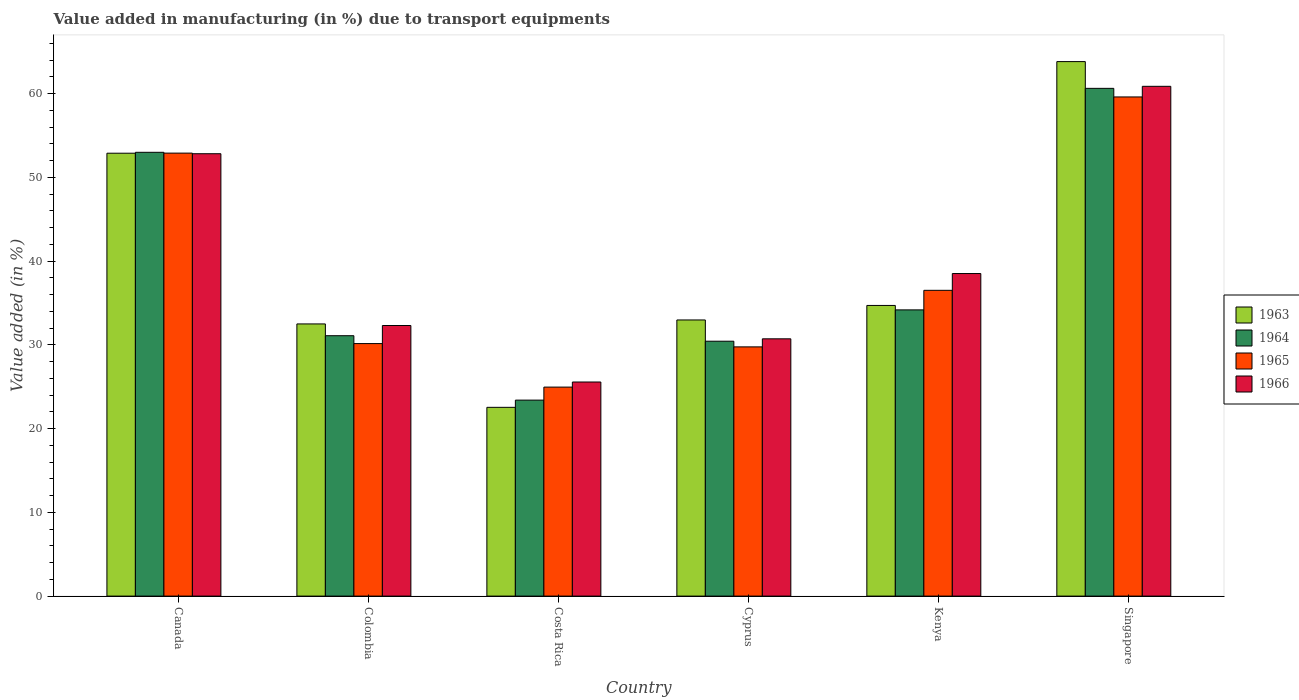How many different coloured bars are there?
Your answer should be compact. 4. How many groups of bars are there?
Keep it short and to the point. 6. How many bars are there on the 1st tick from the left?
Offer a very short reply. 4. What is the label of the 6th group of bars from the left?
Provide a short and direct response. Singapore. In how many cases, is the number of bars for a given country not equal to the number of legend labels?
Keep it short and to the point. 0. What is the percentage of value added in manufacturing due to transport equipments in 1965 in Cyprus?
Your answer should be compact. 29.75. Across all countries, what is the maximum percentage of value added in manufacturing due to transport equipments in 1964?
Provide a short and direct response. 60.62. Across all countries, what is the minimum percentage of value added in manufacturing due to transport equipments in 1964?
Your answer should be very brief. 23.4. In which country was the percentage of value added in manufacturing due to transport equipments in 1965 maximum?
Your response must be concise. Singapore. What is the total percentage of value added in manufacturing due to transport equipments in 1964 in the graph?
Offer a very short reply. 232.68. What is the difference between the percentage of value added in manufacturing due to transport equipments in 1963 in Costa Rica and that in Singapore?
Ensure brevity in your answer.  -41.28. What is the difference between the percentage of value added in manufacturing due to transport equipments in 1966 in Singapore and the percentage of value added in manufacturing due to transport equipments in 1963 in Costa Rica?
Give a very brief answer. 38.33. What is the average percentage of value added in manufacturing due to transport equipments in 1965 per country?
Provide a short and direct response. 38.97. What is the difference between the percentage of value added in manufacturing due to transport equipments of/in 1963 and percentage of value added in manufacturing due to transport equipments of/in 1964 in Colombia?
Give a very brief answer. 1.41. In how many countries, is the percentage of value added in manufacturing due to transport equipments in 1964 greater than 6 %?
Offer a terse response. 6. What is the ratio of the percentage of value added in manufacturing due to transport equipments in 1964 in Costa Rica to that in Kenya?
Give a very brief answer. 0.68. Is the percentage of value added in manufacturing due to transport equipments in 1963 in Colombia less than that in Costa Rica?
Make the answer very short. No. Is the difference between the percentage of value added in manufacturing due to transport equipments in 1963 in Colombia and Kenya greater than the difference between the percentage of value added in manufacturing due to transport equipments in 1964 in Colombia and Kenya?
Provide a succinct answer. Yes. What is the difference between the highest and the second highest percentage of value added in manufacturing due to transport equipments in 1964?
Provide a short and direct response. -26.45. What is the difference between the highest and the lowest percentage of value added in manufacturing due to transport equipments in 1964?
Give a very brief answer. 37.22. In how many countries, is the percentage of value added in manufacturing due to transport equipments in 1963 greater than the average percentage of value added in manufacturing due to transport equipments in 1963 taken over all countries?
Ensure brevity in your answer.  2. Is the sum of the percentage of value added in manufacturing due to transport equipments in 1966 in Cyprus and Singapore greater than the maximum percentage of value added in manufacturing due to transport equipments in 1964 across all countries?
Provide a short and direct response. Yes. What does the 2nd bar from the left in Canada represents?
Keep it short and to the point. 1964. How many bars are there?
Your answer should be very brief. 24. Are all the bars in the graph horizontal?
Offer a very short reply. No. How many countries are there in the graph?
Your response must be concise. 6. Does the graph contain any zero values?
Keep it short and to the point. No. Does the graph contain grids?
Make the answer very short. No. Where does the legend appear in the graph?
Provide a short and direct response. Center right. How many legend labels are there?
Keep it short and to the point. 4. What is the title of the graph?
Make the answer very short. Value added in manufacturing (in %) due to transport equipments. Does "2003" appear as one of the legend labels in the graph?
Keep it short and to the point. No. What is the label or title of the Y-axis?
Give a very brief answer. Value added (in %). What is the Value added (in %) of 1963 in Canada?
Your response must be concise. 52.87. What is the Value added (in %) of 1964 in Canada?
Provide a succinct answer. 52.98. What is the Value added (in %) of 1965 in Canada?
Provide a short and direct response. 52.89. What is the Value added (in %) of 1966 in Canada?
Keep it short and to the point. 52.81. What is the Value added (in %) in 1963 in Colombia?
Give a very brief answer. 32.49. What is the Value added (in %) in 1964 in Colombia?
Provide a short and direct response. 31.09. What is the Value added (in %) in 1965 in Colombia?
Ensure brevity in your answer.  30.15. What is the Value added (in %) of 1966 in Colombia?
Make the answer very short. 32.3. What is the Value added (in %) in 1963 in Costa Rica?
Offer a terse response. 22.53. What is the Value added (in %) in 1964 in Costa Rica?
Offer a terse response. 23.4. What is the Value added (in %) in 1965 in Costa Rica?
Make the answer very short. 24.95. What is the Value added (in %) of 1966 in Costa Rica?
Your response must be concise. 25.56. What is the Value added (in %) of 1963 in Cyprus?
Give a very brief answer. 32.97. What is the Value added (in %) in 1964 in Cyprus?
Ensure brevity in your answer.  30.43. What is the Value added (in %) in 1965 in Cyprus?
Offer a very short reply. 29.75. What is the Value added (in %) in 1966 in Cyprus?
Keep it short and to the point. 30.72. What is the Value added (in %) in 1963 in Kenya?
Provide a succinct answer. 34.7. What is the Value added (in %) in 1964 in Kenya?
Give a very brief answer. 34.17. What is the Value added (in %) of 1965 in Kenya?
Provide a short and direct response. 36.5. What is the Value added (in %) of 1966 in Kenya?
Give a very brief answer. 38.51. What is the Value added (in %) of 1963 in Singapore?
Keep it short and to the point. 63.81. What is the Value added (in %) of 1964 in Singapore?
Your response must be concise. 60.62. What is the Value added (in %) in 1965 in Singapore?
Your response must be concise. 59.59. What is the Value added (in %) of 1966 in Singapore?
Keep it short and to the point. 60.86. Across all countries, what is the maximum Value added (in %) in 1963?
Your answer should be compact. 63.81. Across all countries, what is the maximum Value added (in %) of 1964?
Ensure brevity in your answer.  60.62. Across all countries, what is the maximum Value added (in %) of 1965?
Your response must be concise. 59.59. Across all countries, what is the maximum Value added (in %) of 1966?
Provide a succinct answer. 60.86. Across all countries, what is the minimum Value added (in %) of 1963?
Provide a succinct answer. 22.53. Across all countries, what is the minimum Value added (in %) of 1964?
Make the answer very short. 23.4. Across all countries, what is the minimum Value added (in %) of 1965?
Your response must be concise. 24.95. Across all countries, what is the minimum Value added (in %) of 1966?
Provide a short and direct response. 25.56. What is the total Value added (in %) in 1963 in the graph?
Your response must be concise. 239.38. What is the total Value added (in %) in 1964 in the graph?
Make the answer very short. 232.68. What is the total Value added (in %) in 1965 in the graph?
Your answer should be very brief. 233.83. What is the total Value added (in %) of 1966 in the graph?
Keep it short and to the point. 240.76. What is the difference between the Value added (in %) of 1963 in Canada and that in Colombia?
Give a very brief answer. 20.38. What is the difference between the Value added (in %) in 1964 in Canada and that in Colombia?
Make the answer very short. 21.9. What is the difference between the Value added (in %) of 1965 in Canada and that in Colombia?
Make the answer very short. 22.74. What is the difference between the Value added (in %) of 1966 in Canada and that in Colombia?
Offer a terse response. 20.51. What is the difference between the Value added (in %) in 1963 in Canada and that in Costa Rica?
Offer a terse response. 30.34. What is the difference between the Value added (in %) of 1964 in Canada and that in Costa Rica?
Your answer should be very brief. 29.59. What is the difference between the Value added (in %) in 1965 in Canada and that in Costa Rica?
Your answer should be very brief. 27.93. What is the difference between the Value added (in %) of 1966 in Canada and that in Costa Rica?
Provide a succinct answer. 27.25. What is the difference between the Value added (in %) in 1963 in Canada and that in Cyprus?
Your answer should be very brief. 19.91. What is the difference between the Value added (in %) of 1964 in Canada and that in Cyprus?
Offer a terse response. 22.55. What is the difference between the Value added (in %) in 1965 in Canada and that in Cyprus?
Offer a terse response. 23.13. What is the difference between the Value added (in %) in 1966 in Canada and that in Cyprus?
Offer a terse response. 22.1. What is the difference between the Value added (in %) in 1963 in Canada and that in Kenya?
Your answer should be compact. 18.17. What is the difference between the Value added (in %) of 1964 in Canada and that in Kenya?
Keep it short and to the point. 18.81. What is the difference between the Value added (in %) in 1965 in Canada and that in Kenya?
Make the answer very short. 16.38. What is the difference between the Value added (in %) in 1966 in Canada and that in Kenya?
Give a very brief answer. 14.3. What is the difference between the Value added (in %) in 1963 in Canada and that in Singapore?
Your answer should be compact. -10.94. What is the difference between the Value added (in %) in 1964 in Canada and that in Singapore?
Offer a terse response. -7.63. What is the difference between the Value added (in %) of 1965 in Canada and that in Singapore?
Provide a short and direct response. -6.71. What is the difference between the Value added (in %) of 1966 in Canada and that in Singapore?
Offer a terse response. -8.05. What is the difference between the Value added (in %) in 1963 in Colombia and that in Costa Rica?
Ensure brevity in your answer.  9.96. What is the difference between the Value added (in %) of 1964 in Colombia and that in Costa Rica?
Keep it short and to the point. 7.69. What is the difference between the Value added (in %) of 1965 in Colombia and that in Costa Rica?
Your answer should be compact. 5.2. What is the difference between the Value added (in %) of 1966 in Colombia and that in Costa Rica?
Offer a terse response. 6.74. What is the difference between the Value added (in %) in 1963 in Colombia and that in Cyprus?
Provide a succinct answer. -0.47. What is the difference between the Value added (in %) of 1964 in Colombia and that in Cyprus?
Provide a succinct answer. 0.66. What is the difference between the Value added (in %) of 1965 in Colombia and that in Cyprus?
Provide a short and direct response. 0.39. What is the difference between the Value added (in %) in 1966 in Colombia and that in Cyprus?
Provide a short and direct response. 1.59. What is the difference between the Value added (in %) of 1963 in Colombia and that in Kenya?
Offer a very short reply. -2.21. What is the difference between the Value added (in %) of 1964 in Colombia and that in Kenya?
Your response must be concise. -3.08. What is the difference between the Value added (in %) in 1965 in Colombia and that in Kenya?
Keep it short and to the point. -6.36. What is the difference between the Value added (in %) in 1966 in Colombia and that in Kenya?
Keep it short and to the point. -6.2. What is the difference between the Value added (in %) of 1963 in Colombia and that in Singapore?
Give a very brief answer. -31.32. What is the difference between the Value added (in %) in 1964 in Colombia and that in Singapore?
Provide a succinct answer. -29.53. What is the difference between the Value added (in %) of 1965 in Colombia and that in Singapore?
Make the answer very short. -29.45. What is the difference between the Value added (in %) in 1966 in Colombia and that in Singapore?
Your response must be concise. -28.56. What is the difference between the Value added (in %) of 1963 in Costa Rica and that in Cyprus?
Your answer should be compact. -10.43. What is the difference between the Value added (in %) of 1964 in Costa Rica and that in Cyprus?
Offer a very short reply. -7.03. What is the difference between the Value added (in %) of 1965 in Costa Rica and that in Cyprus?
Offer a very short reply. -4.8. What is the difference between the Value added (in %) in 1966 in Costa Rica and that in Cyprus?
Provide a succinct answer. -5.16. What is the difference between the Value added (in %) in 1963 in Costa Rica and that in Kenya?
Give a very brief answer. -12.17. What is the difference between the Value added (in %) of 1964 in Costa Rica and that in Kenya?
Make the answer very short. -10.77. What is the difference between the Value added (in %) in 1965 in Costa Rica and that in Kenya?
Your answer should be compact. -11.55. What is the difference between the Value added (in %) of 1966 in Costa Rica and that in Kenya?
Your answer should be compact. -12.95. What is the difference between the Value added (in %) in 1963 in Costa Rica and that in Singapore?
Offer a very short reply. -41.28. What is the difference between the Value added (in %) in 1964 in Costa Rica and that in Singapore?
Keep it short and to the point. -37.22. What is the difference between the Value added (in %) of 1965 in Costa Rica and that in Singapore?
Your answer should be very brief. -34.64. What is the difference between the Value added (in %) in 1966 in Costa Rica and that in Singapore?
Offer a terse response. -35.3. What is the difference between the Value added (in %) of 1963 in Cyprus and that in Kenya?
Provide a short and direct response. -1.73. What is the difference between the Value added (in %) of 1964 in Cyprus and that in Kenya?
Give a very brief answer. -3.74. What is the difference between the Value added (in %) in 1965 in Cyprus and that in Kenya?
Your answer should be very brief. -6.75. What is the difference between the Value added (in %) of 1966 in Cyprus and that in Kenya?
Offer a very short reply. -7.79. What is the difference between the Value added (in %) in 1963 in Cyprus and that in Singapore?
Ensure brevity in your answer.  -30.84. What is the difference between the Value added (in %) of 1964 in Cyprus and that in Singapore?
Make the answer very short. -30.19. What is the difference between the Value added (in %) of 1965 in Cyprus and that in Singapore?
Provide a short and direct response. -29.84. What is the difference between the Value added (in %) of 1966 in Cyprus and that in Singapore?
Provide a succinct answer. -30.14. What is the difference between the Value added (in %) of 1963 in Kenya and that in Singapore?
Offer a terse response. -29.11. What is the difference between the Value added (in %) of 1964 in Kenya and that in Singapore?
Make the answer very short. -26.45. What is the difference between the Value added (in %) in 1965 in Kenya and that in Singapore?
Make the answer very short. -23.09. What is the difference between the Value added (in %) of 1966 in Kenya and that in Singapore?
Offer a very short reply. -22.35. What is the difference between the Value added (in %) of 1963 in Canada and the Value added (in %) of 1964 in Colombia?
Ensure brevity in your answer.  21.79. What is the difference between the Value added (in %) in 1963 in Canada and the Value added (in %) in 1965 in Colombia?
Provide a short and direct response. 22.73. What is the difference between the Value added (in %) in 1963 in Canada and the Value added (in %) in 1966 in Colombia?
Make the answer very short. 20.57. What is the difference between the Value added (in %) in 1964 in Canada and the Value added (in %) in 1965 in Colombia?
Keep it short and to the point. 22.84. What is the difference between the Value added (in %) in 1964 in Canada and the Value added (in %) in 1966 in Colombia?
Ensure brevity in your answer.  20.68. What is the difference between the Value added (in %) in 1965 in Canada and the Value added (in %) in 1966 in Colombia?
Keep it short and to the point. 20.58. What is the difference between the Value added (in %) in 1963 in Canada and the Value added (in %) in 1964 in Costa Rica?
Keep it short and to the point. 29.48. What is the difference between the Value added (in %) of 1963 in Canada and the Value added (in %) of 1965 in Costa Rica?
Ensure brevity in your answer.  27.92. What is the difference between the Value added (in %) of 1963 in Canada and the Value added (in %) of 1966 in Costa Rica?
Keep it short and to the point. 27.31. What is the difference between the Value added (in %) in 1964 in Canada and the Value added (in %) in 1965 in Costa Rica?
Offer a very short reply. 28.03. What is the difference between the Value added (in %) of 1964 in Canada and the Value added (in %) of 1966 in Costa Rica?
Your response must be concise. 27.42. What is the difference between the Value added (in %) of 1965 in Canada and the Value added (in %) of 1966 in Costa Rica?
Give a very brief answer. 27.33. What is the difference between the Value added (in %) of 1963 in Canada and the Value added (in %) of 1964 in Cyprus?
Ensure brevity in your answer.  22.44. What is the difference between the Value added (in %) in 1963 in Canada and the Value added (in %) in 1965 in Cyprus?
Keep it short and to the point. 23.12. What is the difference between the Value added (in %) in 1963 in Canada and the Value added (in %) in 1966 in Cyprus?
Keep it short and to the point. 22.16. What is the difference between the Value added (in %) in 1964 in Canada and the Value added (in %) in 1965 in Cyprus?
Your answer should be compact. 23.23. What is the difference between the Value added (in %) of 1964 in Canada and the Value added (in %) of 1966 in Cyprus?
Offer a very short reply. 22.27. What is the difference between the Value added (in %) of 1965 in Canada and the Value added (in %) of 1966 in Cyprus?
Offer a very short reply. 22.17. What is the difference between the Value added (in %) of 1963 in Canada and the Value added (in %) of 1964 in Kenya?
Your answer should be very brief. 18.7. What is the difference between the Value added (in %) in 1963 in Canada and the Value added (in %) in 1965 in Kenya?
Offer a very short reply. 16.37. What is the difference between the Value added (in %) in 1963 in Canada and the Value added (in %) in 1966 in Kenya?
Keep it short and to the point. 14.37. What is the difference between the Value added (in %) in 1964 in Canada and the Value added (in %) in 1965 in Kenya?
Make the answer very short. 16.48. What is the difference between the Value added (in %) in 1964 in Canada and the Value added (in %) in 1966 in Kenya?
Offer a very short reply. 14.47. What is the difference between the Value added (in %) in 1965 in Canada and the Value added (in %) in 1966 in Kenya?
Ensure brevity in your answer.  14.38. What is the difference between the Value added (in %) in 1963 in Canada and the Value added (in %) in 1964 in Singapore?
Your answer should be very brief. -7.74. What is the difference between the Value added (in %) in 1963 in Canada and the Value added (in %) in 1965 in Singapore?
Provide a short and direct response. -6.72. What is the difference between the Value added (in %) in 1963 in Canada and the Value added (in %) in 1966 in Singapore?
Offer a terse response. -7.99. What is the difference between the Value added (in %) in 1964 in Canada and the Value added (in %) in 1965 in Singapore?
Offer a terse response. -6.61. What is the difference between the Value added (in %) of 1964 in Canada and the Value added (in %) of 1966 in Singapore?
Give a very brief answer. -7.88. What is the difference between the Value added (in %) in 1965 in Canada and the Value added (in %) in 1966 in Singapore?
Ensure brevity in your answer.  -7.97. What is the difference between the Value added (in %) of 1963 in Colombia and the Value added (in %) of 1964 in Costa Rica?
Your response must be concise. 9.1. What is the difference between the Value added (in %) of 1963 in Colombia and the Value added (in %) of 1965 in Costa Rica?
Ensure brevity in your answer.  7.54. What is the difference between the Value added (in %) in 1963 in Colombia and the Value added (in %) in 1966 in Costa Rica?
Your answer should be compact. 6.93. What is the difference between the Value added (in %) of 1964 in Colombia and the Value added (in %) of 1965 in Costa Rica?
Offer a terse response. 6.14. What is the difference between the Value added (in %) of 1964 in Colombia and the Value added (in %) of 1966 in Costa Rica?
Offer a very short reply. 5.53. What is the difference between the Value added (in %) of 1965 in Colombia and the Value added (in %) of 1966 in Costa Rica?
Provide a short and direct response. 4.59. What is the difference between the Value added (in %) of 1963 in Colombia and the Value added (in %) of 1964 in Cyprus?
Ensure brevity in your answer.  2.06. What is the difference between the Value added (in %) in 1963 in Colombia and the Value added (in %) in 1965 in Cyprus?
Give a very brief answer. 2.74. What is the difference between the Value added (in %) in 1963 in Colombia and the Value added (in %) in 1966 in Cyprus?
Provide a short and direct response. 1.78. What is the difference between the Value added (in %) in 1964 in Colombia and the Value added (in %) in 1965 in Cyprus?
Provide a succinct answer. 1.33. What is the difference between the Value added (in %) in 1964 in Colombia and the Value added (in %) in 1966 in Cyprus?
Keep it short and to the point. 0.37. What is the difference between the Value added (in %) in 1965 in Colombia and the Value added (in %) in 1966 in Cyprus?
Provide a short and direct response. -0.57. What is the difference between the Value added (in %) of 1963 in Colombia and the Value added (in %) of 1964 in Kenya?
Make the answer very short. -1.68. What is the difference between the Value added (in %) of 1963 in Colombia and the Value added (in %) of 1965 in Kenya?
Offer a very short reply. -4.01. What is the difference between the Value added (in %) of 1963 in Colombia and the Value added (in %) of 1966 in Kenya?
Provide a short and direct response. -6.01. What is the difference between the Value added (in %) of 1964 in Colombia and the Value added (in %) of 1965 in Kenya?
Your answer should be very brief. -5.42. What is the difference between the Value added (in %) in 1964 in Colombia and the Value added (in %) in 1966 in Kenya?
Keep it short and to the point. -7.42. What is the difference between the Value added (in %) of 1965 in Colombia and the Value added (in %) of 1966 in Kenya?
Provide a short and direct response. -8.36. What is the difference between the Value added (in %) of 1963 in Colombia and the Value added (in %) of 1964 in Singapore?
Ensure brevity in your answer.  -28.12. What is the difference between the Value added (in %) of 1963 in Colombia and the Value added (in %) of 1965 in Singapore?
Provide a succinct answer. -27.1. What is the difference between the Value added (in %) in 1963 in Colombia and the Value added (in %) in 1966 in Singapore?
Make the answer very short. -28.37. What is the difference between the Value added (in %) of 1964 in Colombia and the Value added (in %) of 1965 in Singapore?
Ensure brevity in your answer.  -28.51. What is the difference between the Value added (in %) of 1964 in Colombia and the Value added (in %) of 1966 in Singapore?
Make the answer very short. -29.77. What is the difference between the Value added (in %) of 1965 in Colombia and the Value added (in %) of 1966 in Singapore?
Provide a succinct answer. -30.71. What is the difference between the Value added (in %) in 1963 in Costa Rica and the Value added (in %) in 1964 in Cyprus?
Keep it short and to the point. -7.9. What is the difference between the Value added (in %) in 1963 in Costa Rica and the Value added (in %) in 1965 in Cyprus?
Keep it short and to the point. -7.22. What is the difference between the Value added (in %) in 1963 in Costa Rica and the Value added (in %) in 1966 in Cyprus?
Make the answer very short. -8.18. What is the difference between the Value added (in %) in 1964 in Costa Rica and the Value added (in %) in 1965 in Cyprus?
Provide a succinct answer. -6.36. What is the difference between the Value added (in %) in 1964 in Costa Rica and the Value added (in %) in 1966 in Cyprus?
Offer a very short reply. -7.32. What is the difference between the Value added (in %) of 1965 in Costa Rica and the Value added (in %) of 1966 in Cyprus?
Your answer should be very brief. -5.77. What is the difference between the Value added (in %) in 1963 in Costa Rica and the Value added (in %) in 1964 in Kenya?
Provide a short and direct response. -11.64. What is the difference between the Value added (in %) in 1963 in Costa Rica and the Value added (in %) in 1965 in Kenya?
Give a very brief answer. -13.97. What is the difference between the Value added (in %) of 1963 in Costa Rica and the Value added (in %) of 1966 in Kenya?
Provide a short and direct response. -15.97. What is the difference between the Value added (in %) of 1964 in Costa Rica and the Value added (in %) of 1965 in Kenya?
Offer a terse response. -13.11. What is the difference between the Value added (in %) in 1964 in Costa Rica and the Value added (in %) in 1966 in Kenya?
Make the answer very short. -15.11. What is the difference between the Value added (in %) of 1965 in Costa Rica and the Value added (in %) of 1966 in Kenya?
Give a very brief answer. -13.56. What is the difference between the Value added (in %) of 1963 in Costa Rica and the Value added (in %) of 1964 in Singapore?
Provide a succinct answer. -38.08. What is the difference between the Value added (in %) of 1963 in Costa Rica and the Value added (in %) of 1965 in Singapore?
Offer a very short reply. -37.06. What is the difference between the Value added (in %) in 1963 in Costa Rica and the Value added (in %) in 1966 in Singapore?
Provide a short and direct response. -38.33. What is the difference between the Value added (in %) in 1964 in Costa Rica and the Value added (in %) in 1965 in Singapore?
Provide a succinct answer. -36.19. What is the difference between the Value added (in %) of 1964 in Costa Rica and the Value added (in %) of 1966 in Singapore?
Your answer should be very brief. -37.46. What is the difference between the Value added (in %) in 1965 in Costa Rica and the Value added (in %) in 1966 in Singapore?
Offer a very short reply. -35.91. What is the difference between the Value added (in %) of 1963 in Cyprus and the Value added (in %) of 1964 in Kenya?
Provide a short and direct response. -1.2. What is the difference between the Value added (in %) in 1963 in Cyprus and the Value added (in %) in 1965 in Kenya?
Your answer should be very brief. -3.54. What is the difference between the Value added (in %) of 1963 in Cyprus and the Value added (in %) of 1966 in Kenya?
Offer a terse response. -5.54. What is the difference between the Value added (in %) of 1964 in Cyprus and the Value added (in %) of 1965 in Kenya?
Offer a terse response. -6.07. What is the difference between the Value added (in %) of 1964 in Cyprus and the Value added (in %) of 1966 in Kenya?
Provide a short and direct response. -8.08. What is the difference between the Value added (in %) of 1965 in Cyprus and the Value added (in %) of 1966 in Kenya?
Provide a succinct answer. -8.75. What is the difference between the Value added (in %) of 1963 in Cyprus and the Value added (in %) of 1964 in Singapore?
Keep it short and to the point. -27.65. What is the difference between the Value added (in %) of 1963 in Cyprus and the Value added (in %) of 1965 in Singapore?
Provide a succinct answer. -26.62. What is the difference between the Value added (in %) of 1963 in Cyprus and the Value added (in %) of 1966 in Singapore?
Ensure brevity in your answer.  -27.89. What is the difference between the Value added (in %) of 1964 in Cyprus and the Value added (in %) of 1965 in Singapore?
Your response must be concise. -29.16. What is the difference between the Value added (in %) of 1964 in Cyprus and the Value added (in %) of 1966 in Singapore?
Ensure brevity in your answer.  -30.43. What is the difference between the Value added (in %) of 1965 in Cyprus and the Value added (in %) of 1966 in Singapore?
Offer a terse response. -31.11. What is the difference between the Value added (in %) in 1963 in Kenya and the Value added (in %) in 1964 in Singapore?
Your response must be concise. -25.92. What is the difference between the Value added (in %) of 1963 in Kenya and the Value added (in %) of 1965 in Singapore?
Make the answer very short. -24.89. What is the difference between the Value added (in %) of 1963 in Kenya and the Value added (in %) of 1966 in Singapore?
Your answer should be compact. -26.16. What is the difference between the Value added (in %) of 1964 in Kenya and the Value added (in %) of 1965 in Singapore?
Provide a short and direct response. -25.42. What is the difference between the Value added (in %) of 1964 in Kenya and the Value added (in %) of 1966 in Singapore?
Provide a short and direct response. -26.69. What is the difference between the Value added (in %) in 1965 in Kenya and the Value added (in %) in 1966 in Singapore?
Provide a short and direct response. -24.36. What is the average Value added (in %) of 1963 per country?
Your response must be concise. 39.9. What is the average Value added (in %) in 1964 per country?
Your answer should be compact. 38.78. What is the average Value added (in %) of 1965 per country?
Your answer should be compact. 38.97. What is the average Value added (in %) of 1966 per country?
Offer a terse response. 40.13. What is the difference between the Value added (in %) of 1963 and Value added (in %) of 1964 in Canada?
Offer a terse response. -0.11. What is the difference between the Value added (in %) in 1963 and Value added (in %) in 1965 in Canada?
Keep it short and to the point. -0.01. What is the difference between the Value added (in %) in 1963 and Value added (in %) in 1966 in Canada?
Your answer should be very brief. 0.06. What is the difference between the Value added (in %) in 1964 and Value added (in %) in 1965 in Canada?
Your response must be concise. 0.1. What is the difference between the Value added (in %) in 1964 and Value added (in %) in 1966 in Canada?
Offer a very short reply. 0.17. What is the difference between the Value added (in %) in 1965 and Value added (in %) in 1966 in Canada?
Your answer should be very brief. 0.07. What is the difference between the Value added (in %) in 1963 and Value added (in %) in 1964 in Colombia?
Offer a very short reply. 1.41. What is the difference between the Value added (in %) in 1963 and Value added (in %) in 1965 in Colombia?
Your response must be concise. 2.35. What is the difference between the Value added (in %) of 1963 and Value added (in %) of 1966 in Colombia?
Make the answer very short. 0.19. What is the difference between the Value added (in %) of 1964 and Value added (in %) of 1965 in Colombia?
Your answer should be very brief. 0.94. What is the difference between the Value added (in %) of 1964 and Value added (in %) of 1966 in Colombia?
Make the answer very short. -1.22. What is the difference between the Value added (in %) of 1965 and Value added (in %) of 1966 in Colombia?
Keep it short and to the point. -2.16. What is the difference between the Value added (in %) in 1963 and Value added (in %) in 1964 in Costa Rica?
Keep it short and to the point. -0.86. What is the difference between the Value added (in %) of 1963 and Value added (in %) of 1965 in Costa Rica?
Your response must be concise. -2.42. What is the difference between the Value added (in %) of 1963 and Value added (in %) of 1966 in Costa Rica?
Give a very brief answer. -3.03. What is the difference between the Value added (in %) in 1964 and Value added (in %) in 1965 in Costa Rica?
Offer a terse response. -1.55. What is the difference between the Value added (in %) of 1964 and Value added (in %) of 1966 in Costa Rica?
Your answer should be compact. -2.16. What is the difference between the Value added (in %) in 1965 and Value added (in %) in 1966 in Costa Rica?
Your answer should be very brief. -0.61. What is the difference between the Value added (in %) of 1963 and Value added (in %) of 1964 in Cyprus?
Ensure brevity in your answer.  2.54. What is the difference between the Value added (in %) of 1963 and Value added (in %) of 1965 in Cyprus?
Offer a very short reply. 3.21. What is the difference between the Value added (in %) of 1963 and Value added (in %) of 1966 in Cyprus?
Ensure brevity in your answer.  2.25. What is the difference between the Value added (in %) in 1964 and Value added (in %) in 1965 in Cyprus?
Your answer should be very brief. 0.68. What is the difference between the Value added (in %) in 1964 and Value added (in %) in 1966 in Cyprus?
Your answer should be compact. -0.29. What is the difference between the Value added (in %) in 1965 and Value added (in %) in 1966 in Cyprus?
Your response must be concise. -0.96. What is the difference between the Value added (in %) of 1963 and Value added (in %) of 1964 in Kenya?
Provide a short and direct response. 0.53. What is the difference between the Value added (in %) in 1963 and Value added (in %) in 1965 in Kenya?
Give a very brief answer. -1.8. What is the difference between the Value added (in %) in 1963 and Value added (in %) in 1966 in Kenya?
Give a very brief answer. -3.81. What is the difference between the Value added (in %) in 1964 and Value added (in %) in 1965 in Kenya?
Your answer should be very brief. -2.33. What is the difference between the Value added (in %) of 1964 and Value added (in %) of 1966 in Kenya?
Make the answer very short. -4.34. What is the difference between the Value added (in %) in 1965 and Value added (in %) in 1966 in Kenya?
Your answer should be compact. -2. What is the difference between the Value added (in %) of 1963 and Value added (in %) of 1964 in Singapore?
Your answer should be compact. 3.19. What is the difference between the Value added (in %) in 1963 and Value added (in %) in 1965 in Singapore?
Offer a very short reply. 4.22. What is the difference between the Value added (in %) of 1963 and Value added (in %) of 1966 in Singapore?
Keep it short and to the point. 2.95. What is the difference between the Value added (in %) of 1964 and Value added (in %) of 1965 in Singapore?
Your answer should be very brief. 1.03. What is the difference between the Value added (in %) of 1964 and Value added (in %) of 1966 in Singapore?
Offer a very short reply. -0.24. What is the difference between the Value added (in %) of 1965 and Value added (in %) of 1966 in Singapore?
Make the answer very short. -1.27. What is the ratio of the Value added (in %) in 1963 in Canada to that in Colombia?
Offer a terse response. 1.63. What is the ratio of the Value added (in %) in 1964 in Canada to that in Colombia?
Make the answer very short. 1.7. What is the ratio of the Value added (in %) in 1965 in Canada to that in Colombia?
Give a very brief answer. 1.75. What is the ratio of the Value added (in %) of 1966 in Canada to that in Colombia?
Offer a very short reply. 1.63. What is the ratio of the Value added (in %) of 1963 in Canada to that in Costa Rica?
Ensure brevity in your answer.  2.35. What is the ratio of the Value added (in %) of 1964 in Canada to that in Costa Rica?
Keep it short and to the point. 2.26. What is the ratio of the Value added (in %) in 1965 in Canada to that in Costa Rica?
Your answer should be very brief. 2.12. What is the ratio of the Value added (in %) of 1966 in Canada to that in Costa Rica?
Provide a short and direct response. 2.07. What is the ratio of the Value added (in %) in 1963 in Canada to that in Cyprus?
Your answer should be compact. 1.6. What is the ratio of the Value added (in %) of 1964 in Canada to that in Cyprus?
Make the answer very short. 1.74. What is the ratio of the Value added (in %) in 1965 in Canada to that in Cyprus?
Offer a terse response. 1.78. What is the ratio of the Value added (in %) in 1966 in Canada to that in Cyprus?
Ensure brevity in your answer.  1.72. What is the ratio of the Value added (in %) in 1963 in Canada to that in Kenya?
Give a very brief answer. 1.52. What is the ratio of the Value added (in %) of 1964 in Canada to that in Kenya?
Provide a succinct answer. 1.55. What is the ratio of the Value added (in %) of 1965 in Canada to that in Kenya?
Offer a very short reply. 1.45. What is the ratio of the Value added (in %) of 1966 in Canada to that in Kenya?
Provide a succinct answer. 1.37. What is the ratio of the Value added (in %) of 1963 in Canada to that in Singapore?
Make the answer very short. 0.83. What is the ratio of the Value added (in %) in 1964 in Canada to that in Singapore?
Your answer should be compact. 0.87. What is the ratio of the Value added (in %) in 1965 in Canada to that in Singapore?
Give a very brief answer. 0.89. What is the ratio of the Value added (in %) in 1966 in Canada to that in Singapore?
Offer a terse response. 0.87. What is the ratio of the Value added (in %) of 1963 in Colombia to that in Costa Rica?
Your answer should be very brief. 1.44. What is the ratio of the Value added (in %) in 1964 in Colombia to that in Costa Rica?
Give a very brief answer. 1.33. What is the ratio of the Value added (in %) in 1965 in Colombia to that in Costa Rica?
Offer a very short reply. 1.21. What is the ratio of the Value added (in %) of 1966 in Colombia to that in Costa Rica?
Give a very brief answer. 1.26. What is the ratio of the Value added (in %) of 1963 in Colombia to that in Cyprus?
Your answer should be compact. 0.99. What is the ratio of the Value added (in %) of 1964 in Colombia to that in Cyprus?
Provide a short and direct response. 1.02. What is the ratio of the Value added (in %) in 1965 in Colombia to that in Cyprus?
Your answer should be very brief. 1.01. What is the ratio of the Value added (in %) of 1966 in Colombia to that in Cyprus?
Offer a terse response. 1.05. What is the ratio of the Value added (in %) of 1963 in Colombia to that in Kenya?
Provide a short and direct response. 0.94. What is the ratio of the Value added (in %) of 1964 in Colombia to that in Kenya?
Your answer should be very brief. 0.91. What is the ratio of the Value added (in %) of 1965 in Colombia to that in Kenya?
Offer a very short reply. 0.83. What is the ratio of the Value added (in %) of 1966 in Colombia to that in Kenya?
Ensure brevity in your answer.  0.84. What is the ratio of the Value added (in %) of 1963 in Colombia to that in Singapore?
Your answer should be very brief. 0.51. What is the ratio of the Value added (in %) in 1964 in Colombia to that in Singapore?
Your answer should be very brief. 0.51. What is the ratio of the Value added (in %) in 1965 in Colombia to that in Singapore?
Your response must be concise. 0.51. What is the ratio of the Value added (in %) in 1966 in Colombia to that in Singapore?
Provide a short and direct response. 0.53. What is the ratio of the Value added (in %) of 1963 in Costa Rica to that in Cyprus?
Your answer should be very brief. 0.68. What is the ratio of the Value added (in %) of 1964 in Costa Rica to that in Cyprus?
Offer a terse response. 0.77. What is the ratio of the Value added (in %) of 1965 in Costa Rica to that in Cyprus?
Make the answer very short. 0.84. What is the ratio of the Value added (in %) of 1966 in Costa Rica to that in Cyprus?
Provide a succinct answer. 0.83. What is the ratio of the Value added (in %) in 1963 in Costa Rica to that in Kenya?
Make the answer very short. 0.65. What is the ratio of the Value added (in %) in 1964 in Costa Rica to that in Kenya?
Ensure brevity in your answer.  0.68. What is the ratio of the Value added (in %) of 1965 in Costa Rica to that in Kenya?
Your response must be concise. 0.68. What is the ratio of the Value added (in %) in 1966 in Costa Rica to that in Kenya?
Provide a short and direct response. 0.66. What is the ratio of the Value added (in %) of 1963 in Costa Rica to that in Singapore?
Your answer should be very brief. 0.35. What is the ratio of the Value added (in %) of 1964 in Costa Rica to that in Singapore?
Your response must be concise. 0.39. What is the ratio of the Value added (in %) in 1965 in Costa Rica to that in Singapore?
Keep it short and to the point. 0.42. What is the ratio of the Value added (in %) in 1966 in Costa Rica to that in Singapore?
Keep it short and to the point. 0.42. What is the ratio of the Value added (in %) of 1963 in Cyprus to that in Kenya?
Your answer should be very brief. 0.95. What is the ratio of the Value added (in %) of 1964 in Cyprus to that in Kenya?
Ensure brevity in your answer.  0.89. What is the ratio of the Value added (in %) of 1965 in Cyprus to that in Kenya?
Give a very brief answer. 0.82. What is the ratio of the Value added (in %) of 1966 in Cyprus to that in Kenya?
Provide a short and direct response. 0.8. What is the ratio of the Value added (in %) of 1963 in Cyprus to that in Singapore?
Provide a short and direct response. 0.52. What is the ratio of the Value added (in %) of 1964 in Cyprus to that in Singapore?
Give a very brief answer. 0.5. What is the ratio of the Value added (in %) of 1965 in Cyprus to that in Singapore?
Your response must be concise. 0.5. What is the ratio of the Value added (in %) in 1966 in Cyprus to that in Singapore?
Your answer should be compact. 0.5. What is the ratio of the Value added (in %) in 1963 in Kenya to that in Singapore?
Keep it short and to the point. 0.54. What is the ratio of the Value added (in %) of 1964 in Kenya to that in Singapore?
Ensure brevity in your answer.  0.56. What is the ratio of the Value added (in %) in 1965 in Kenya to that in Singapore?
Give a very brief answer. 0.61. What is the ratio of the Value added (in %) in 1966 in Kenya to that in Singapore?
Ensure brevity in your answer.  0.63. What is the difference between the highest and the second highest Value added (in %) in 1963?
Make the answer very short. 10.94. What is the difference between the highest and the second highest Value added (in %) of 1964?
Provide a short and direct response. 7.63. What is the difference between the highest and the second highest Value added (in %) of 1965?
Provide a short and direct response. 6.71. What is the difference between the highest and the second highest Value added (in %) of 1966?
Provide a succinct answer. 8.05. What is the difference between the highest and the lowest Value added (in %) of 1963?
Provide a succinct answer. 41.28. What is the difference between the highest and the lowest Value added (in %) of 1964?
Offer a very short reply. 37.22. What is the difference between the highest and the lowest Value added (in %) in 1965?
Give a very brief answer. 34.64. What is the difference between the highest and the lowest Value added (in %) in 1966?
Provide a succinct answer. 35.3. 